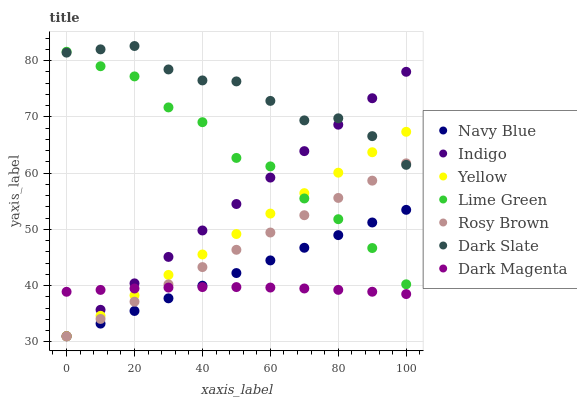Does Dark Magenta have the minimum area under the curve?
Answer yes or no. Yes. Does Dark Slate have the maximum area under the curve?
Answer yes or no. Yes. Does Navy Blue have the minimum area under the curve?
Answer yes or no. No. Does Navy Blue have the maximum area under the curve?
Answer yes or no. No. Is Navy Blue the smoothest?
Answer yes or no. Yes. Is Lime Green the roughest?
Answer yes or no. Yes. Is Dark Magenta the smoothest?
Answer yes or no. No. Is Dark Magenta the roughest?
Answer yes or no. No. Does Indigo have the lowest value?
Answer yes or no. Yes. Does Dark Magenta have the lowest value?
Answer yes or no. No. Does Dark Slate have the highest value?
Answer yes or no. Yes. Does Navy Blue have the highest value?
Answer yes or no. No. Is Navy Blue less than Dark Slate?
Answer yes or no. Yes. Is Dark Slate greater than Dark Magenta?
Answer yes or no. Yes. Does Dark Slate intersect Yellow?
Answer yes or no. Yes. Is Dark Slate less than Yellow?
Answer yes or no. No. Is Dark Slate greater than Yellow?
Answer yes or no. No. Does Navy Blue intersect Dark Slate?
Answer yes or no. No. 